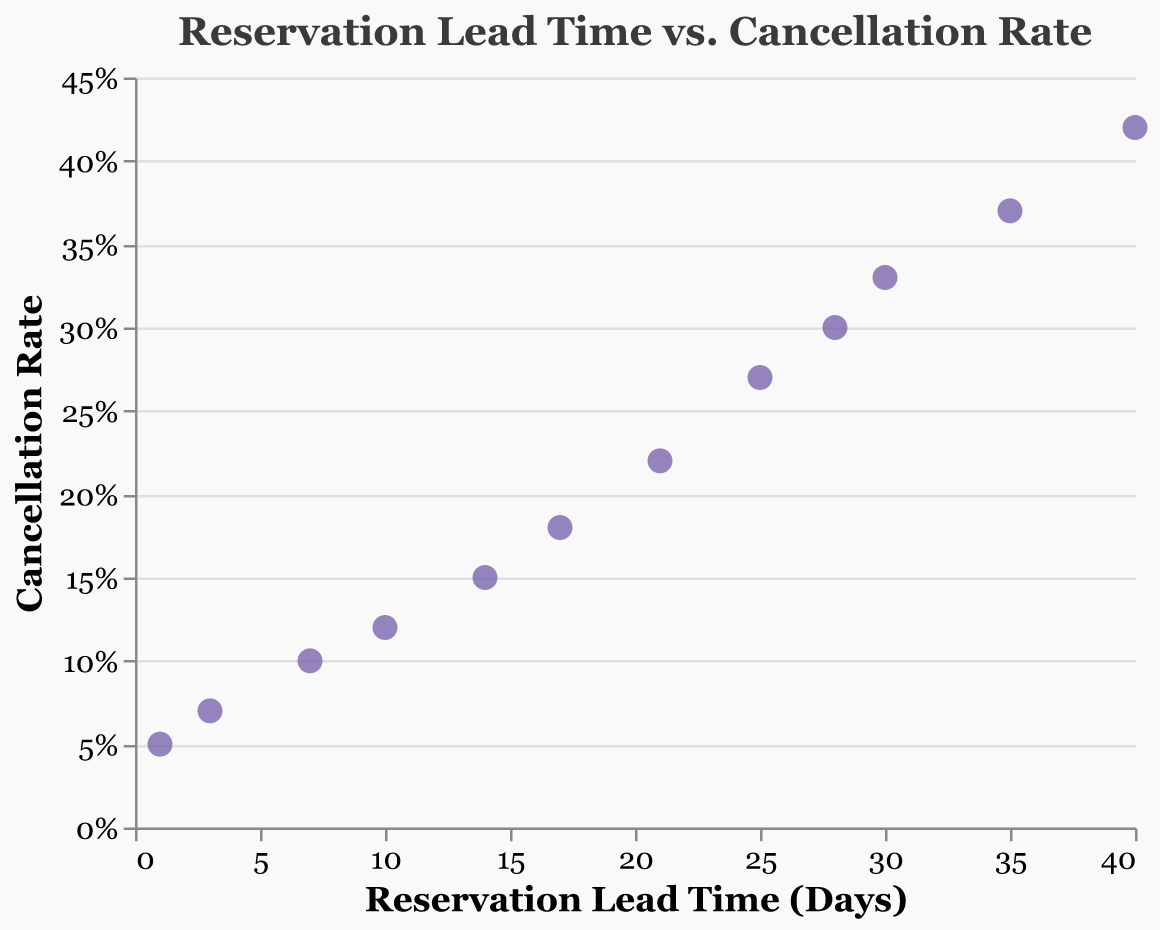How many data points are on the scatter plot? Count the number of points plotted. There are 12 points in the scatter plot.
Answer: 12 What is the title of the scatter plot? The title is located at the top center of the plot. The title of the scatter plot is "Reservation Lead Time vs. Cancellation Rate".
Answer: Reservation Lead Time vs. Cancellation Rate What is the color of the points on the scatter plot? The color of the points can be identified by looking at the markers on the plot. The color of the points on the scatter plot is purple.
Answer: Purple Which axis represents the Reservation Lead Time? Identify the axis by reading the axis titles. The x-axis represents the Reservation Lead Time.
Answer: x-axis What is the cancellation rate when the lead time is 10 days? Locate the point where the lead time is 10 on the x-axis and check its corresponding y value. The cancellation rate when the lead time is 10 days is 0.12.
Answer: 0.12 What is the difference in cancellation rate between a lead time of 30 days and 7 days? Find the y-values for lead times of 30 days and 7 days, then subtract the smaller value from the larger one. The difference is 0.33 - 0.1 = 0.23.
Answer: 0.23 How does the cancellation rate change as the reservation lead time increases from 1 day to 40 days? Observe the trend of the points from left to right. The cancellation rate increases as the reservation lead time increases from 1 day to 40 days.
Answer: It increases What is the average cancellation rate for the lead times of 14 days, 17 days, and 21 days? Find the y-values for these lead times and calculate their average. (0.15 + 0.18 + 0.22) / 3 = 0.1833.
Answer: 0.1833 At what lead time is the cancellation rate closest to 0.3? Look for the point closest to the cancellation rate of 0.3. The lead time is 28 days when the cancellation rate is closest to 0.3.
Answer: 28 days What can you infer about the relationship between reservation lead time and cancellation rate? Interpret the overall trend in the scatter plot. As the reservation lead time increases, the cancellation rate tends to increase as well, suggesting a positive correlation.
Answer: Positive correlation 